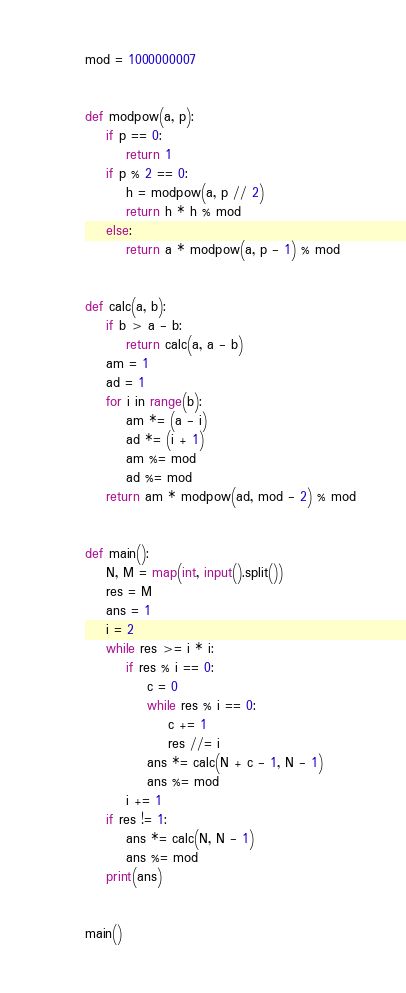Convert code to text. <code><loc_0><loc_0><loc_500><loc_500><_Python_>mod = 1000000007


def modpow(a, p):
    if p == 0:
        return 1
    if p % 2 == 0:
        h = modpow(a, p // 2)
        return h * h % mod
    else:
        return a * modpow(a, p - 1) % mod


def calc(a, b):
    if b > a - b:
        return calc(a, a - b)
    am = 1
    ad = 1
    for i in range(b):
        am *= (a - i)
        ad *= (i + 1)
        am %= mod
        ad %= mod
    return am * modpow(ad, mod - 2) % mod


def main():
    N, M = map(int, input().split())
    res = M
    ans = 1
    i = 2
    while res >= i * i:
        if res % i == 0:
            c = 0
            while res % i == 0:
                c += 1
                res //= i
            ans *= calc(N + c - 1, N - 1)
            ans %= mod
        i += 1
    if res != 1:
        ans *= calc(N, N - 1)
        ans %= mod
    print(ans)


main()
</code> 